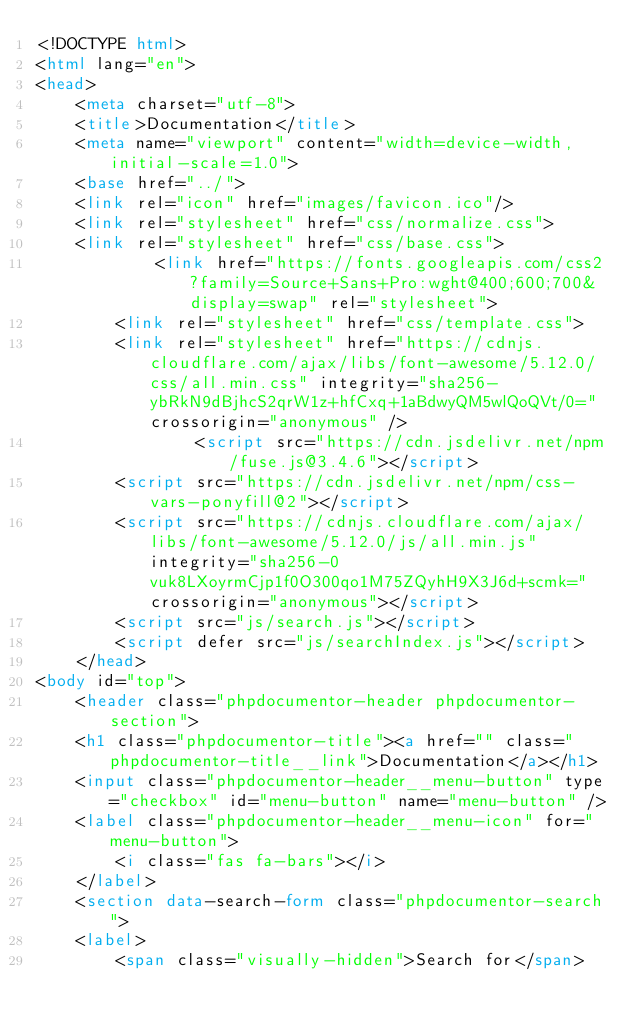Convert code to text. <code><loc_0><loc_0><loc_500><loc_500><_HTML_><!DOCTYPE html>
<html lang="en">
<head>
    <meta charset="utf-8">
    <title>Documentation</title>
    <meta name="viewport" content="width=device-width, initial-scale=1.0">
    <base href="../">
    <link rel="icon" href="images/favicon.ico"/>
    <link rel="stylesheet" href="css/normalize.css">
    <link rel="stylesheet" href="css/base.css">
            <link href="https://fonts.googleapis.com/css2?family=Source+Sans+Pro:wght@400;600;700&display=swap" rel="stylesheet">
        <link rel="stylesheet" href="css/template.css">
        <link rel="stylesheet" href="https://cdnjs.cloudflare.com/ajax/libs/font-awesome/5.12.0/css/all.min.css" integrity="sha256-ybRkN9dBjhcS2qrW1z+hfCxq+1aBdwyQM5wlQoQVt/0=" crossorigin="anonymous" />
                <script src="https://cdn.jsdelivr.net/npm/fuse.js@3.4.6"></script>
        <script src="https://cdn.jsdelivr.net/npm/css-vars-ponyfill@2"></script>
        <script src="https://cdnjs.cloudflare.com/ajax/libs/font-awesome/5.12.0/js/all.min.js" integrity="sha256-0vuk8LXoyrmCjp1f0O300qo1M75ZQyhH9X3J6d+scmk=" crossorigin="anonymous"></script>
        <script src="js/search.js"></script>
        <script defer src="js/searchIndex.js"></script>
    </head>
<body id="top">
    <header class="phpdocumentor-header phpdocumentor-section">
    <h1 class="phpdocumentor-title"><a href="" class="phpdocumentor-title__link">Documentation</a></h1>
    <input class="phpdocumentor-header__menu-button" type="checkbox" id="menu-button" name="menu-button" />
    <label class="phpdocumentor-header__menu-icon" for="menu-button">
        <i class="fas fa-bars"></i>
    </label>
    <section data-search-form class="phpdocumentor-search">
    <label>
        <span class="visually-hidden">Search for</span></code> 